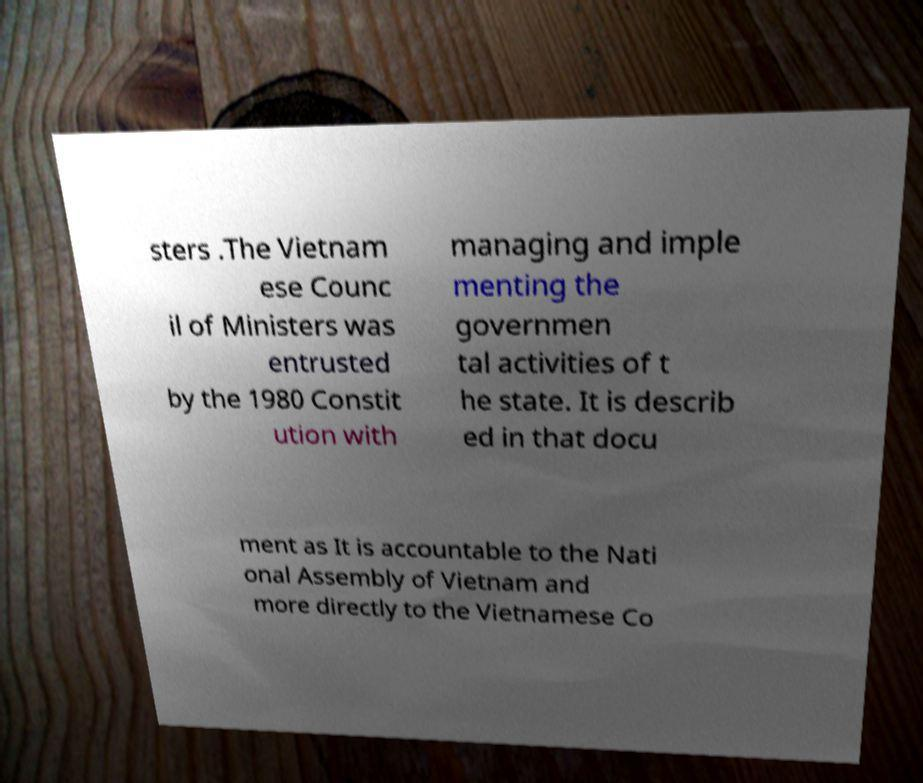There's text embedded in this image that I need extracted. Can you transcribe it verbatim? sters .The Vietnam ese Counc il of Ministers was entrusted by the 1980 Constit ution with managing and imple menting the governmen tal activities of t he state. It is describ ed in that docu ment as It is accountable to the Nati onal Assembly of Vietnam and more directly to the Vietnamese Co 